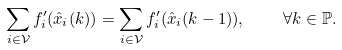Convert formula to latex. <formula><loc_0><loc_0><loc_500><loc_500>\sum _ { i \in \mathcal { V } } f _ { i } ^ { \prime } ( \hat { x } _ { i } ( k ) ) = \sum _ { i \in \mathcal { V } } f _ { i } ^ { \prime } ( \hat { x } _ { i } ( k - 1 ) ) , \quad \forall k \in \mathbb { P } .</formula> 